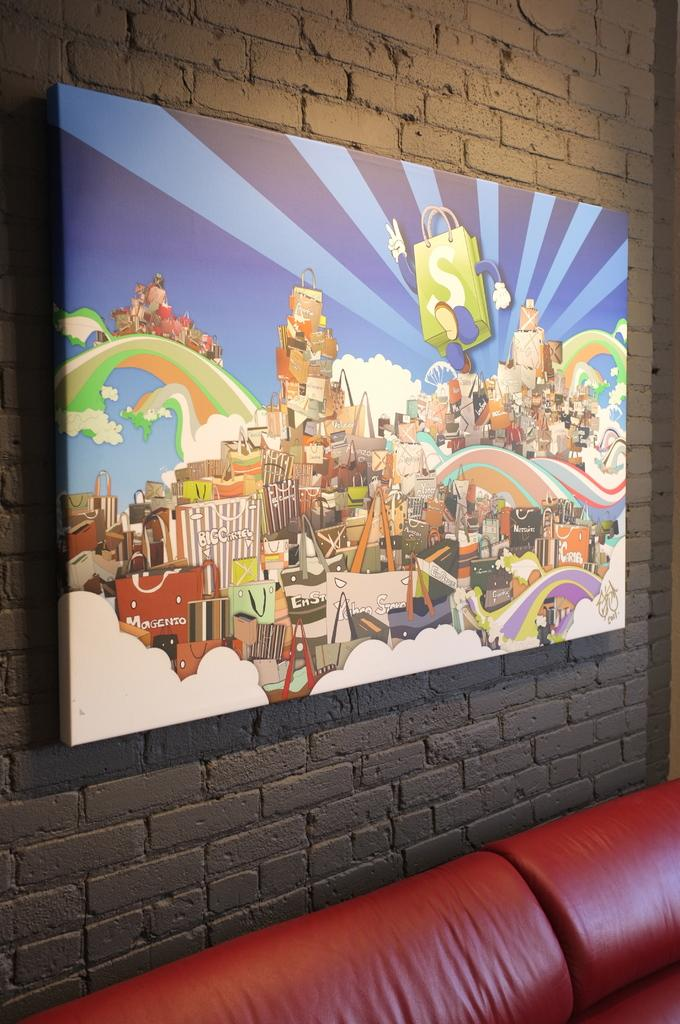What type of furniture is present in the image? There is a sofa in the image. What can be seen in the background of the image? There is a wall in the background of the image. Are there any decorative items on the wall? Yes, there is a photo frame on the wall in the background. What type of root can be seen growing from the sofa in the image? There is no root growing from the sofa in the image. 